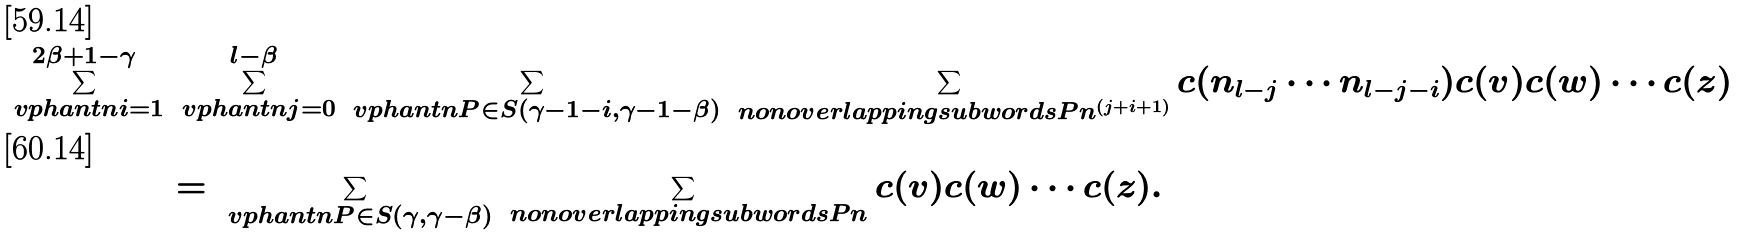<formula> <loc_0><loc_0><loc_500><loc_500>\sum _ { \ v p h a n t n i = 1 } ^ { 2 \beta + 1 - \gamma } & \sum _ { \ v p h a n t n j = 0 } ^ { l - \beta } \sum _ { \ v p h a n t n P \in S ( \gamma - 1 - i , \gamma - 1 - \beta ) } \sum _ { \ n o n o v e r l a p p i n g s u b w o r d s { P } { n ^ { ( j + i + 1 ) } } } c ( n _ { l - j } \cdots n _ { l - j - i } ) c ( v ) c ( w ) \cdots c ( z ) \\ & = \sum _ { \ v p h a n t n P \in S ( \gamma , \gamma - \beta ) } \sum _ { \ n o n o v e r l a p p i n g s u b w o r d s { P } { n } } c ( v ) c ( w ) \cdots c ( z ) .</formula> 